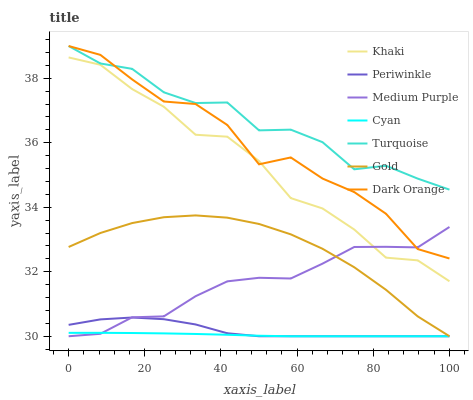Does Cyan have the minimum area under the curve?
Answer yes or no. Yes. Does Turquoise have the maximum area under the curve?
Answer yes or no. Yes. Does Khaki have the minimum area under the curve?
Answer yes or no. No. Does Khaki have the maximum area under the curve?
Answer yes or no. No. Is Cyan the smoothest?
Answer yes or no. Yes. Is Dark Orange the roughest?
Answer yes or no. Yes. Is Turquoise the smoothest?
Answer yes or no. No. Is Turquoise the roughest?
Answer yes or no. No. Does Gold have the lowest value?
Answer yes or no. Yes. Does Khaki have the lowest value?
Answer yes or no. No. Does Turquoise have the highest value?
Answer yes or no. Yes. Does Khaki have the highest value?
Answer yes or no. No. Is Cyan less than Khaki?
Answer yes or no. Yes. Is Dark Orange greater than Cyan?
Answer yes or no. Yes. Does Cyan intersect Medium Purple?
Answer yes or no. Yes. Is Cyan less than Medium Purple?
Answer yes or no. No. Is Cyan greater than Medium Purple?
Answer yes or no. No. Does Cyan intersect Khaki?
Answer yes or no. No. 